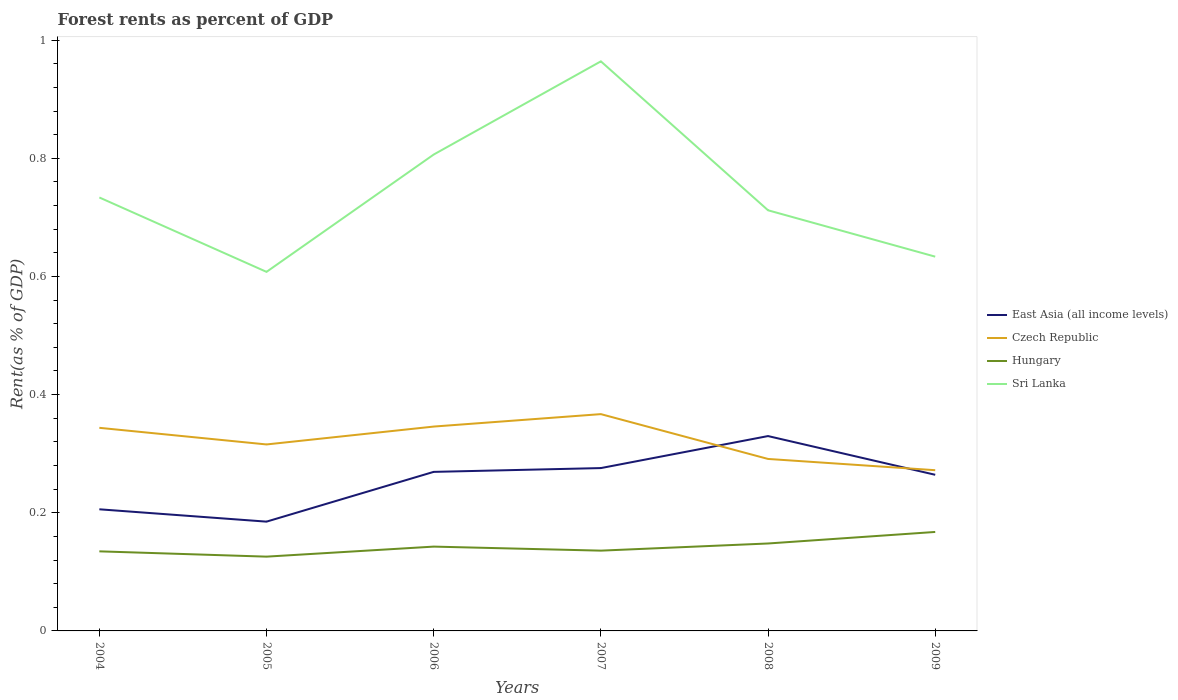How many different coloured lines are there?
Provide a succinct answer. 4. Is the number of lines equal to the number of legend labels?
Provide a short and direct response. Yes. Across all years, what is the maximum forest rent in East Asia (all income levels)?
Your answer should be compact. 0.18. What is the total forest rent in East Asia (all income levels) in the graph?
Provide a short and direct response. -0.01. What is the difference between the highest and the second highest forest rent in East Asia (all income levels)?
Provide a short and direct response. 0.14. How many years are there in the graph?
Provide a short and direct response. 6. What is the difference between two consecutive major ticks on the Y-axis?
Offer a very short reply. 0.2. Are the values on the major ticks of Y-axis written in scientific E-notation?
Provide a succinct answer. No. How many legend labels are there?
Keep it short and to the point. 4. What is the title of the graph?
Your answer should be compact. Forest rents as percent of GDP. Does "Haiti" appear as one of the legend labels in the graph?
Provide a short and direct response. No. What is the label or title of the Y-axis?
Offer a terse response. Rent(as % of GDP). What is the Rent(as % of GDP) in East Asia (all income levels) in 2004?
Make the answer very short. 0.21. What is the Rent(as % of GDP) in Czech Republic in 2004?
Provide a succinct answer. 0.34. What is the Rent(as % of GDP) of Hungary in 2004?
Your answer should be very brief. 0.13. What is the Rent(as % of GDP) in Sri Lanka in 2004?
Keep it short and to the point. 0.73. What is the Rent(as % of GDP) in East Asia (all income levels) in 2005?
Offer a very short reply. 0.18. What is the Rent(as % of GDP) in Czech Republic in 2005?
Ensure brevity in your answer.  0.32. What is the Rent(as % of GDP) of Hungary in 2005?
Give a very brief answer. 0.13. What is the Rent(as % of GDP) of Sri Lanka in 2005?
Offer a terse response. 0.61. What is the Rent(as % of GDP) of East Asia (all income levels) in 2006?
Your answer should be compact. 0.27. What is the Rent(as % of GDP) in Czech Republic in 2006?
Offer a very short reply. 0.35. What is the Rent(as % of GDP) of Hungary in 2006?
Your response must be concise. 0.14. What is the Rent(as % of GDP) in Sri Lanka in 2006?
Give a very brief answer. 0.81. What is the Rent(as % of GDP) in East Asia (all income levels) in 2007?
Offer a very short reply. 0.28. What is the Rent(as % of GDP) of Czech Republic in 2007?
Ensure brevity in your answer.  0.37. What is the Rent(as % of GDP) of Hungary in 2007?
Ensure brevity in your answer.  0.14. What is the Rent(as % of GDP) in Sri Lanka in 2007?
Your answer should be very brief. 0.96. What is the Rent(as % of GDP) in East Asia (all income levels) in 2008?
Offer a very short reply. 0.33. What is the Rent(as % of GDP) of Czech Republic in 2008?
Your response must be concise. 0.29. What is the Rent(as % of GDP) in Hungary in 2008?
Your response must be concise. 0.15. What is the Rent(as % of GDP) in Sri Lanka in 2008?
Make the answer very short. 0.71. What is the Rent(as % of GDP) in East Asia (all income levels) in 2009?
Make the answer very short. 0.26. What is the Rent(as % of GDP) in Czech Republic in 2009?
Make the answer very short. 0.27. What is the Rent(as % of GDP) in Hungary in 2009?
Your response must be concise. 0.17. What is the Rent(as % of GDP) of Sri Lanka in 2009?
Provide a short and direct response. 0.63. Across all years, what is the maximum Rent(as % of GDP) in East Asia (all income levels)?
Offer a terse response. 0.33. Across all years, what is the maximum Rent(as % of GDP) of Czech Republic?
Your answer should be very brief. 0.37. Across all years, what is the maximum Rent(as % of GDP) in Hungary?
Keep it short and to the point. 0.17. Across all years, what is the maximum Rent(as % of GDP) in Sri Lanka?
Make the answer very short. 0.96. Across all years, what is the minimum Rent(as % of GDP) in East Asia (all income levels)?
Provide a short and direct response. 0.18. Across all years, what is the minimum Rent(as % of GDP) in Czech Republic?
Offer a very short reply. 0.27. Across all years, what is the minimum Rent(as % of GDP) in Hungary?
Your answer should be very brief. 0.13. Across all years, what is the minimum Rent(as % of GDP) in Sri Lanka?
Keep it short and to the point. 0.61. What is the total Rent(as % of GDP) of East Asia (all income levels) in the graph?
Give a very brief answer. 1.53. What is the total Rent(as % of GDP) in Czech Republic in the graph?
Keep it short and to the point. 1.94. What is the total Rent(as % of GDP) of Hungary in the graph?
Offer a terse response. 0.85. What is the total Rent(as % of GDP) in Sri Lanka in the graph?
Make the answer very short. 4.46. What is the difference between the Rent(as % of GDP) in East Asia (all income levels) in 2004 and that in 2005?
Offer a very short reply. 0.02. What is the difference between the Rent(as % of GDP) in Czech Republic in 2004 and that in 2005?
Make the answer very short. 0.03. What is the difference between the Rent(as % of GDP) in Hungary in 2004 and that in 2005?
Your answer should be compact. 0.01. What is the difference between the Rent(as % of GDP) in Sri Lanka in 2004 and that in 2005?
Your answer should be very brief. 0.13. What is the difference between the Rent(as % of GDP) in East Asia (all income levels) in 2004 and that in 2006?
Offer a very short reply. -0.06. What is the difference between the Rent(as % of GDP) in Czech Republic in 2004 and that in 2006?
Offer a terse response. -0. What is the difference between the Rent(as % of GDP) of Hungary in 2004 and that in 2006?
Ensure brevity in your answer.  -0.01. What is the difference between the Rent(as % of GDP) of Sri Lanka in 2004 and that in 2006?
Keep it short and to the point. -0.07. What is the difference between the Rent(as % of GDP) in East Asia (all income levels) in 2004 and that in 2007?
Provide a short and direct response. -0.07. What is the difference between the Rent(as % of GDP) of Czech Republic in 2004 and that in 2007?
Offer a very short reply. -0.02. What is the difference between the Rent(as % of GDP) of Hungary in 2004 and that in 2007?
Provide a short and direct response. -0. What is the difference between the Rent(as % of GDP) in Sri Lanka in 2004 and that in 2007?
Ensure brevity in your answer.  -0.23. What is the difference between the Rent(as % of GDP) of East Asia (all income levels) in 2004 and that in 2008?
Give a very brief answer. -0.12. What is the difference between the Rent(as % of GDP) in Czech Republic in 2004 and that in 2008?
Your response must be concise. 0.05. What is the difference between the Rent(as % of GDP) in Hungary in 2004 and that in 2008?
Your answer should be compact. -0.01. What is the difference between the Rent(as % of GDP) in Sri Lanka in 2004 and that in 2008?
Keep it short and to the point. 0.02. What is the difference between the Rent(as % of GDP) of East Asia (all income levels) in 2004 and that in 2009?
Make the answer very short. -0.06. What is the difference between the Rent(as % of GDP) of Czech Republic in 2004 and that in 2009?
Offer a very short reply. 0.07. What is the difference between the Rent(as % of GDP) of Hungary in 2004 and that in 2009?
Provide a short and direct response. -0.03. What is the difference between the Rent(as % of GDP) in Sri Lanka in 2004 and that in 2009?
Give a very brief answer. 0.1. What is the difference between the Rent(as % of GDP) of East Asia (all income levels) in 2005 and that in 2006?
Make the answer very short. -0.08. What is the difference between the Rent(as % of GDP) of Czech Republic in 2005 and that in 2006?
Your response must be concise. -0.03. What is the difference between the Rent(as % of GDP) of Hungary in 2005 and that in 2006?
Your answer should be compact. -0.02. What is the difference between the Rent(as % of GDP) in Sri Lanka in 2005 and that in 2006?
Keep it short and to the point. -0.2. What is the difference between the Rent(as % of GDP) of East Asia (all income levels) in 2005 and that in 2007?
Make the answer very short. -0.09. What is the difference between the Rent(as % of GDP) of Czech Republic in 2005 and that in 2007?
Keep it short and to the point. -0.05. What is the difference between the Rent(as % of GDP) of Hungary in 2005 and that in 2007?
Ensure brevity in your answer.  -0.01. What is the difference between the Rent(as % of GDP) in Sri Lanka in 2005 and that in 2007?
Make the answer very short. -0.36. What is the difference between the Rent(as % of GDP) in East Asia (all income levels) in 2005 and that in 2008?
Provide a succinct answer. -0.14. What is the difference between the Rent(as % of GDP) in Czech Republic in 2005 and that in 2008?
Offer a very short reply. 0.02. What is the difference between the Rent(as % of GDP) in Hungary in 2005 and that in 2008?
Your response must be concise. -0.02. What is the difference between the Rent(as % of GDP) of Sri Lanka in 2005 and that in 2008?
Offer a very short reply. -0.1. What is the difference between the Rent(as % of GDP) of East Asia (all income levels) in 2005 and that in 2009?
Your response must be concise. -0.08. What is the difference between the Rent(as % of GDP) of Czech Republic in 2005 and that in 2009?
Offer a very short reply. 0.04. What is the difference between the Rent(as % of GDP) of Hungary in 2005 and that in 2009?
Ensure brevity in your answer.  -0.04. What is the difference between the Rent(as % of GDP) in Sri Lanka in 2005 and that in 2009?
Offer a very short reply. -0.03. What is the difference between the Rent(as % of GDP) in East Asia (all income levels) in 2006 and that in 2007?
Your response must be concise. -0.01. What is the difference between the Rent(as % of GDP) of Czech Republic in 2006 and that in 2007?
Offer a very short reply. -0.02. What is the difference between the Rent(as % of GDP) of Hungary in 2006 and that in 2007?
Offer a very short reply. 0.01. What is the difference between the Rent(as % of GDP) in Sri Lanka in 2006 and that in 2007?
Your response must be concise. -0.16. What is the difference between the Rent(as % of GDP) of East Asia (all income levels) in 2006 and that in 2008?
Your answer should be very brief. -0.06. What is the difference between the Rent(as % of GDP) of Czech Republic in 2006 and that in 2008?
Ensure brevity in your answer.  0.05. What is the difference between the Rent(as % of GDP) in Hungary in 2006 and that in 2008?
Keep it short and to the point. -0.01. What is the difference between the Rent(as % of GDP) in Sri Lanka in 2006 and that in 2008?
Keep it short and to the point. 0.09. What is the difference between the Rent(as % of GDP) of East Asia (all income levels) in 2006 and that in 2009?
Provide a succinct answer. 0.01. What is the difference between the Rent(as % of GDP) in Czech Republic in 2006 and that in 2009?
Keep it short and to the point. 0.07. What is the difference between the Rent(as % of GDP) in Hungary in 2006 and that in 2009?
Offer a very short reply. -0.02. What is the difference between the Rent(as % of GDP) of Sri Lanka in 2006 and that in 2009?
Ensure brevity in your answer.  0.17. What is the difference between the Rent(as % of GDP) of East Asia (all income levels) in 2007 and that in 2008?
Provide a short and direct response. -0.05. What is the difference between the Rent(as % of GDP) of Czech Republic in 2007 and that in 2008?
Offer a terse response. 0.08. What is the difference between the Rent(as % of GDP) of Hungary in 2007 and that in 2008?
Make the answer very short. -0.01. What is the difference between the Rent(as % of GDP) in Sri Lanka in 2007 and that in 2008?
Keep it short and to the point. 0.25. What is the difference between the Rent(as % of GDP) of East Asia (all income levels) in 2007 and that in 2009?
Provide a short and direct response. 0.01. What is the difference between the Rent(as % of GDP) of Czech Republic in 2007 and that in 2009?
Provide a short and direct response. 0.09. What is the difference between the Rent(as % of GDP) of Hungary in 2007 and that in 2009?
Your response must be concise. -0.03. What is the difference between the Rent(as % of GDP) of Sri Lanka in 2007 and that in 2009?
Provide a succinct answer. 0.33. What is the difference between the Rent(as % of GDP) of East Asia (all income levels) in 2008 and that in 2009?
Your answer should be very brief. 0.07. What is the difference between the Rent(as % of GDP) in Czech Republic in 2008 and that in 2009?
Offer a terse response. 0.02. What is the difference between the Rent(as % of GDP) in Hungary in 2008 and that in 2009?
Offer a very short reply. -0.02. What is the difference between the Rent(as % of GDP) of Sri Lanka in 2008 and that in 2009?
Give a very brief answer. 0.08. What is the difference between the Rent(as % of GDP) of East Asia (all income levels) in 2004 and the Rent(as % of GDP) of Czech Republic in 2005?
Keep it short and to the point. -0.11. What is the difference between the Rent(as % of GDP) in East Asia (all income levels) in 2004 and the Rent(as % of GDP) in Hungary in 2005?
Keep it short and to the point. 0.08. What is the difference between the Rent(as % of GDP) of East Asia (all income levels) in 2004 and the Rent(as % of GDP) of Sri Lanka in 2005?
Give a very brief answer. -0.4. What is the difference between the Rent(as % of GDP) of Czech Republic in 2004 and the Rent(as % of GDP) of Hungary in 2005?
Provide a succinct answer. 0.22. What is the difference between the Rent(as % of GDP) in Czech Republic in 2004 and the Rent(as % of GDP) in Sri Lanka in 2005?
Provide a short and direct response. -0.26. What is the difference between the Rent(as % of GDP) in Hungary in 2004 and the Rent(as % of GDP) in Sri Lanka in 2005?
Ensure brevity in your answer.  -0.47. What is the difference between the Rent(as % of GDP) in East Asia (all income levels) in 2004 and the Rent(as % of GDP) in Czech Republic in 2006?
Your response must be concise. -0.14. What is the difference between the Rent(as % of GDP) in East Asia (all income levels) in 2004 and the Rent(as % of GDP) in Hungary in 2006?
Ensure brevity in your answer.  0.06. What is the difference between the Rent(as % of GDP) of East Asia (all income levels) in 2004 and the Rent(as % of GDP) of Sri Lanka in 2006?
Make the answer very short. -0.6. What is the difference between the Rent(as % of GDP) of Czech Republic in 2004 and the Rent(as % of GDP) of Hungary in 2006?
Your answer should be compact. 0.2. What is the difference between the Rent(as % of GDP) in Czech Republic in 2004 and the Rent(as % of GDP) in Sri Lanka in 2006?
Keep it short and to the point. -0.46. What is the difference between the Rent(as % of GDP) in Hungary in 2004 and the Rent(as % of GDP) in Sri Lanka in 2006?
Ensure brevity in your answer.  -0.67. What is the difference between the Rent(as % of GDP) in East Asia (all income levels) in 2004 and the Rent(as % of GDP) in Czech Republic in 2007?
Offer a very short reply. -0.16. What is the difference between the Rent(as % of GDP) in East Asia (all income levels) in 2004 and the Rent(as % of GDP) in Hungary in 2007?
Offer a very short reply. 0.07. What is the difference between the Rent(as % of GDP) of East Asia (all income levels) in 2004 and the Rent(as % of GDP) of Sri Lanka in 2007?
Keep it short and to the point. -0.76. What is the difference between the Rent(as % of GDP) in Czech Republic in 2004 and the Rent(as % of GDP) in Hungary in 2007?
Offer a terse response. 0.21. What is the difference between the Rent(as % of GDP) in Czech Republic in 2004 and the Rent(as % of GDP) in Sri Lanka in 2007?
Provide a succinct answer. -0.62. What is the difference between the Rent(as % of GDP) of Hungary in 2004 and the Rent(as % of GDP) of Sri Lanka in 2007?
Provide a short and direct response. -0.83. What is the difference between the Rent(as % of GDP) in East Asia (all income levels) in 2004 and the Rent(as % of GDP) in Czech Republic in 2008?
Your response must be concise. -0.09. What is the difference between the Rent(as % of GDP) in East Asia (all income levels) in 2004 and the Rent(as % of GDP) in Hungary in 2008?
Your response must be concise. 0.06. What is the difference between the Rent(as % of GDP) of East Asia (all income levels) in 2004 and the Rent(as % of GDP) of Sri Lanka in 2008?
Your answer should be very brief. -0.51. What is the difference between the Rent(as % of GDP) in Czech Republic in 2004 and the Rent(as % of GDP) in Hungary in 2008?
Your response must be concise. 0.2. What is the difference between the Rent(as % of GDP) in Czech Republic in 2004 and the Rent(as % of GDP) in Sri Lanka in 2008?
Offer a terse response. -0.37. What is the difference between the Rent(as % of GDP) of Hungary in 2004 and the Rent(as % of GDP) of Sri Lanka in 2008?
Provide a short and direct response. -0.58. What is the difference between the Rent(as % of GDP) in East Asia (all income levels) in 2004 and the Rent(as % of GDP) in Czech Republic in 2009?
Make the answer very short. -0.07. What is the difference between the Rent(as % of GDP) in East Asia (all income levels) in 2004 and the Rent(as % of GDP) in Hungary in 2009?
Your answer should be compact. 0.04. What is the difference between the Rent(as % of GDP) in East Asia (all income levels) in 2004 and the Rent(as % of GDP) in Sri Lanka in 2009?
Offer a very short reply. -0.43. What is the difference between the Rent(as % of GDP) of Czech Republic in 2004 and the Rent(as % of GDP) of Hungary in 2009?
Offer a terse response. 0.18. What is the difference between the Rent(as % of GDP) in Czech Republic in 2004 and the Rent(as % of GDP) in Sri Lanka in 2009?
Make the answer very short. -0.29. What is the difference between the Rent(as % of GDP) in Hungary in 2004 and the Rent(as % of GDP) in Sri Lanka in 2009?
Your answer should be very brief. -0.5. What is the difference between the Rent(as % of GDP) in East Asia (all income levels) in 2005 and the Rent(as % of GDP) in Czech Republic in 2006?
Your response must be concise. -0.16. What is the difference between the Rent(as % of GDP) of East Asia (all income levels) in 2005 and the Rent(as % of GDP) of Hungary in 2006?
Ensure brevity in your answer.  0.04. What is the difference between the Rent(as % of GDP) of East Asia (all income levels) in 2005 and the Rent(as % of GDP) of Sri Lanka in 2006?
Make the answer very short. -0.62. What is the difference between the Rent(as % of GDP) in Czech Republic in 2005 and the Rent(as % of GDP) in Hungary in 2006?
Offer a terse response. 0.17. What is the difference between the Rent(as % of GDP) of Czech Republic in 2005 and the Rent(as % of GDP) of Sri Lanka in 2006?
Your response must be concise. -0.49. What is the difference between the Rent(as % of GDP) in Hungary in 2005 and the Rent(as % of GDP) in Sri Lanka in 2006?
Your answer should be compact. -0.68. What is the difference between the Rent(as % of GDP) in East Asia (all income levels) in 2005 and the Rent(as % of GDP) in Czech Republic in 2007?
Provide a short and direct response. -0.18. What is the difference between the Rent(as % of GDP) of East Asia (all income levels) in 2005 and the Rent(as % of GDP) of Hungary in 2007?
Give a very brief answer. 0.05. What is the difference between the Rent(as % of GDP) in East Asia (all income levels) in 2005 and the Rent(as % of GDP) in Sri Lanka in 2007?
Your response must be concise. -0.78. What is the difference between the Rent(as % of GDP) of Czech Republic in 2005 and the Rent(as % of GDP) of Hungary in 2007?
Your response must be concise. 0.18. What is the difference between the Rent(as % of GDP) in Czech Republic in 2005 and the Rent(as % of GDP) in Sri Lanka in 2007?
Ensure brevity in your answer.  -0.65. What is the difference between the Rent(as % of GDP) of Hungary in 2005 and the Rent(as % of GDP) of Sri Lanka in 2007?
Provide a succinct answer. -0.84. What is the difference between the Rent(as % of GDP) of East Asia (all income levels) in 2005 and the Rent(as % of GDP) of Czech Republic in 2008?
Provide a short and direct response. -0.11. What is the difference between the Rent(as % of GDP) of East Asia (all income levels) in 2005 and the Rent(as % of GDP) of Hungary in 2008?
Your answer should be compact. 0.04. What is the difference between the Rent(as % of GDP) of East Asia (all income levels) in 2005 and the Rent(as % of GDP) of Sri Lanka in 2008?
Ensure brevity in your answer.  -0.53. What is the difference between the Rent(as % of GDP) in Czech Republic in 2005 and the Rent(as % of GDP) in Hungary in 2008?
Make the answer very short. 0.17. What is the difference between the Rent(as % of GDP) in Czech Republic in 2005 and the Rent(as % of GDP) in Sri Lanka in 2008?
Your answer should be very brief. -0.4. What is the difference between the Rent(as % of GDP) in Hungary in 2005 and the Rent(as % of GDP) in Sri Lanka in 2008?
Your response must be concise. -0.59. What is the difference between the Rent(as % of GDP) of East Asia (all income levels) in 2005 and the Rent(as % of GDP) of Czech Republic in 2009?
Provide a short and direct response. -0.09. What is the difference between the Rent(as % of GDP) of East Asia (all income levels) in 2005 and the Rent(as % of GDP) of Hungary in 2009?
Offer a terse response. 0.02. What is the difference between the Rent(as % of GDP) in East Asia (all income levels) in 2005 and the Rent(as % of GDP) in Sri Lanka in 2009?
Ensure brevity in your answer.  -0.45. What is the difference between the Rent(as % of GDP) of Czech Republic in 2005 and the Rent(as % of GDP) of Hungary in 2009?
Provide a succinct answer. 0.15. What is the difference between the Rent(as % of GDP) in Czech Republic in 2005 and the Rent(as % of GDP) in Sri Lanka in 2009?
Provide a short and direct response. -0.32. What is the difference between the Rent(as % of GDP) in Hungary in 2005 and the Rent(as % of GDP) in Sri Lanka in 2009?
Offer a terse response. -0.51. What is the difference between the Rent(as % of GDP) of East Asia (all income levels) in 2006 and the Rent(as % of GDP) of Czech Republic in 2007?
Offer a terse response. -0.1. What is the difference between the Rent(as % of GDP) in East Asia (all income levels) in 2006 and the Rent(as % of GDP) in Hungary in 2007?
Provide a succinct answer. 0.13. What is the difference between the Rent(as % of GDP) in East Asia (all income levels) in 2006 and the Rent(as % of GDP) in Sri Lanka in 2007?
Offer a very short reply. -0.69. What is the difference between the Rent(as % of GDP) of Czech Republic in 2006 and the Rent(as % of GDP) of Hungary in 2007?
Your answer should be very brief. 0.21. What is the difference between the Rent(as % of GDP) in Czech Republic in 2006 and the Rent(as % of GDP) in Sri Lanka in 2007?
Your response must be concise. -0.62. What is the difference between the Rent(as % of GDP) of Hungary in 2006 and the Rent(as % of GDP) of Sri Lanka in 2007?
Give a very brief answer. -0.82. What is the difference between the Rent(as % of GDP) of East Asia (all income levels) in 2006 and the Rent(as % of GDP) of Czech Republic in 2008?
Offer a very short reply. -0.02. What is the difference between the Rent(as % of GDP) in East Asia (all income levels) in 2006 and the Rent(as % of GDP) in Hungary in 2008?
Offer a very short reply. 0.12. What is the difference between the Rent(as % of GDP) in East Asia (all income levels) in 2006 and the Rent(as % of GDP) in Sri Lanka in 2008?
Your answer should be very brief. -0.44. What is the difference between the Rent(as % of GDP) in Czech Republic in 2006 and the Rent(as % of GDP) in Hungary in 2008?
Offer a terse response. 0.2. What is the difference between the Rent(as % of GDP) of Czech Republic in 2006 and the Rent(as % of GDP) of Sri Lanka in 2008?
Give a very brief answer. -0.37. What is the difference between the Rent(as % of GDP) in Hungary in 2006 and the Rent(as % of GDP) in Sri Lanka in 2008?
Your answer should be very brief. -0.57. What is the difference between the Rent(as % of GDP) of East Asia (all income levels) in 2006 and the Rent(as % of GDP) of Czech Republic in 2009?
Keep it short and to the point. -0. What is the difference between the Rent(as % of GDP) in East Asia (all income levels) in 2006 and the Rent(as % of GDP) in Hungary in 2009?
Your answer should be very brief. 0.1. What is the difference between the Rent(as % of GDP) of East Asia (all income levels) in 2006 and the Rent(as % of GDP) of Sri Lanka in 2009?
Provide a short and direct response. -0.36. What is the difference between the Rent(as % of GDP) of Czech Republic in 2006 and the Rent(as % of GDP) of Hungary in 2009?
Give a very brief answer. 0.18. What is the difference between the Rent(as % of GDP) of Czech Republic in 2006 and the Rent(as % of GDP) of Sri Lanka in 2009?
Keep it short and to the point. -0.29. What is the difference between the Rent(as % of GDP) of Hungary in 2006 and the Rent(as % of GDP) of Sri Lanka in 2009?
Your answer should be very brief. -0.49. What is the difference between the Rent(as % of GDP) of East Asia (all income levels) in 2007 and the Rent(as % of GDP) of Czech Republic in 2008?
Ensure brevity in your answer.  -0.02. What is the difference between the Rent(as % of GDP) in East Asia (all income levels) in 2007 and the Rent(as % of GDP) in Hungary in 2008?
Offer a very short reply. 0.13. What is the difference between the Rent(as % of GDP) of East Asia (all income levels) in 2007 and the Rent(as % of GDP) of Sri Lanka in 2008?
Offer a very short reply. -0.44. What is the difference between the Rent(as % of GDP) in Czech Republic in 2007 and the Rent(as % of GDP) in Hungary in 2008?
Your response must be concise. 0.22. What is the difference between the Rent(as % of GDP) of Czech Republic in 2007 and the Rent(as % of GDP) of Sri Lanka in 2008?
Give a very brief answer. -0.35. What is the difference between the Rent(as % of GDP) in Hungary in 2007 and the Rent(as % of GDP) in Sri Lanka in 2008?
Your answer should be very brief. -0.58. What is the difference between the Rent(as % of GDP) in East Asia (all income levels) in 2007 and the Rent(as % of GDP) in Czech Republic in 2009?
Keep it short and to the point. 0. What is the difference between the Rent(as % of GDP) of East Asia (all income levels) in 2007 and the Rent(as % of GDP) of Hungary in 2009?
Keep it short and to the point. 0.11. What is the difference between the Rent(as % of GDP) in East Asia (all income levels) in 2007 and the Rent(as % of GDP) in Sri Lanka in 2009?
Offer a terse response. -0.36. What is the difference between the Rent(as % of GDP) in Czech Republic in 2007 and the Rent(as % of GDP) in Hungary in 2009?
Keep it short and to the point. 0.2. What is the difference between the Rent(as % of GDP) of Czech Republic in 2007 and the Rent(as % of GDP) of Sri Lanka in 2009?
Your response must be concise. -0.27. What is the difference between the Rent(as % of GDP) of Hungary in 2007 and the Rent(as % of GDP) of Sri Lanka in 2009?
Your answer should be very brief. -0.5. What is the difference between the Rent(as % of GDP) of East Asia (all income levels) in 2008 and the Rent(as % of GDP) of Czech Republic in 2009?
Your answer should be compact. 0.06. What is the difference between the Rent(as % of GDP) in East Asia (all income levels) in 2008 and the Rent(as % of GDP) in Hungary in 2009?
Your answer should be very brief. 0.16. What is the difference between the Rent(as % of GDP) of East Asia (all income levels) in 2008 and the Rent(as % of GDP) of Sri Lanka in 2009?
Offer a very short reply. -0.3. What is the difference between the Rent(as % of GDP) of Czech Republic in 2008 and the Rent(as % of GDP) of Hungary in 2009?
Keep it short and to the point. 0.12. What is the difference between the Rent(as % of GDP) in Czech Republic in 2008 and the Rent(as % of GDP) in Sri Lanka in 2009?
Offer a very short reply. -0.34. What is the difference between the Rent(as % of GDP) of Hungary in 2008 and the Rent(as % of GDP) of Sri Lanka in 2009?
Give a very brief answer. -0.49. What is the average Rent(as % of GDP) of East Asia (all income levels) per year?
Your answer should be compact. 0.26. What is the average Rent(as % of GDP) in Czech Republic per year?
Your response must be concise. 0.32. What is the average Rent(as % of GDP) in Hungary per year?
Your answer should be very brief. 0.14. What is the average Rent(as % of GDP) of Sri Lanka per year?
Offer a terse response. 0.74. In the year 2004, what is the difference between the Rent(as % of GDP) in East Asia (all income levels) and Rent(as % of GDP) in Czech Republic?
Your answer should be compact. -0.14. In the year 2004, what is the difference between the Rent(as % of GDP) in East Asia (all income levels) and Rent(as % of GDP) in Hungary?
Provide a short and direct response. 0.07. In the year 2004, what is the difference between the Rent(as % of GDP) of East Asia (all income levels) and Rent(as % of GDP) of Sri Lanka?
Provide a short and direct response. -0.53. In the year 2004, what is the difference between the Rent(as % of GDP) of Czech Republic and Rent(as % of GDP) of Hungary?
Offer a terse response. 0.21. In the year 2004, what is the difference between the Rent(as % of GDP) in Czech Republic and Rent(as % of GDP) in Sri Lanka?
Offer a terse response. -0.39. In the year 2004, what is the difference between the Rent(as % of GDP) of Hungary and Rent(as % of GDP) of Sri Lanka?
Give a very brief answer. -0.6. In the year 2005, what is the difference between the Rent(as % of GDP) in East Asia (all income levels) and Rent(as % of GDP) in Czech Republic?
Offer a terse response. -0.13. In the year 2005, what is the difference between the Rent(as % of GDP) in East Asia (all income levels) and Rent(as % of GDP) in Hungary?
Give a very brief answer. 0.06. In the year 2005, what is the difference between the Rent(as % of GDP) of East Asia (all income levels) and Rent(as % of GDP) of Sri Lanka?
Provide a short and direct response. -0.42. In the year 2005, what is the difference between the Rent(as % of GDP) of Czech Republic and Rent(as % of GDP) of Hungary?
Keep it short and to the point. 0.19. In the year 2005, what is the difference between the Rent(as % of GDP) of Czech Republic and Rent(as % of GDP) of Sri Lanka?
Provide a succinct answer. -0.29. In the year 2005, what is the difference between the Rent(as % of GDP) in Hungary and Rent(as % of GDP) in Sri Lanka?
Give a very brief answer. -0.48. In the year 2006, what is the difference between the Rent(as % of GDP) of East Asia (all income levels) and Rent(as % of GDP) of Czech Republic?
Your answer should be compact. -0.08. In the year 2006, what is the difference between the Rent(as % of GDP) of East Asia (all income levels) and Rent(as % of GDP) of Hungary?
Your response must be concise. 0.13. In the year 2006, what is the difference between the Rent(as % of GDP) of East Asia (all income levels) and Rent(as % of GDP) of Sri Lanka?
Your response must be concise. -0.54. In the year 2006, what is the difference between the Rent(as % of GDP) in Czech Republic and Rent(as % of GDP) in Hungary?
Your answer should be very brief. 0.2. In the year 2006, what is the difference between the Rent(as % of GDP) of Czech Republic and Rent(as % of GDP) of Sri Lanka?
Your answer should be compact. -0.46. In the year 2006, what is the difference between the Rent(as % of GDP) in Hungary and Rent(as % of GDP) in Sri Lanka?
Offer a terse response. -0.66. In the year 2007, what is the difference between the Rent(as % of GDP) of East Asia (all income levels) and Rent(as % of GDP) of Czech Republic?
Your response must be concise. -0.09. In the year 2007, what is the difference between the Rent(as % of GDP) of East Asia (all income levels) and Rent(as % of GDP) of Hungary?
Offer a terse response. 0.14. In the year 2007, what is the difference between the Rent(as % of GDP) of East Asia (all income levels) and Rent(as % of GDP) of Sri Lanka?
Your response must be concise. -0.69. In the year 2007, what is the difference between the Rent(as % of GDP) in Czech Republic and Rent(as % of GDP) in Hungary?
Your answer should be very brief. 0.23. In the year 2007, what is the difference between the Rent(as % of GDP) of Czech Republic and Rent(as % of GDP) of Sri Lanka?
Your answer should be very brief. -0.6. In the year 2007, what is the difference between the Rent(as % of GDP) of Hungary and Rent(as % of GDP) of Sri Lanka?
Provide a short and direct response. -0.83. In the year 2008, what is the difference between the Rent(as % of GDP) in East Asia (all income levels) and Rent(as % of GDP) in Czech Republic?
Give a very brief answer. 0.04. In the year 2008, what is the difference between the Rent(as % of GDP) of East Asia (all income levels) and Rent(as % of GDP) of Hungary?
Your response must be concise. 0.18. In the year 2008, what is the difference between the Rent(as % of GDP) of East Asia (all income levels) and Rent(as % of GDP) of Sri Lanka?
Provide a succinct answer. -0.38. In the year 2008, what is the difference between the Rent(as % of GDP) of Czech Republic and Rent(as % of GDP) of Hungary?
Provide a succinct answer. 0.14. In the year 2008, what is the difference between the Rent(as % of GDP) in Czech Republic and Rent(as % of GDP) in Sri Lanka?
Your answer should be very brief. -0.42. In the year 2008, what is the difference between the Rent(as % of GDP) of Hungary and Rent(as % of GDP) of Sri Lanka?
Make the answer very short. -0.56. In the year 2009, what is the difference between the Rent(as % of GDP) in East Asia (all income levels) and Rent(as % of GDP) in Czech Republic?
Offer a terse response. -0.01. In the year 2009, what is the difference between the Rent(as % of GDP) in East Asia (all income levels) and Rent(as % of GDP) in Hungary?
Provide a succinct answer. 0.1. In the year 2009, what is the difference between the Rent(as % of GDP) of East Asia (all income levels) and Rent(as % of GDP) of Sri Lanka?
Offer a very short reply. -0.37. In the year 2009, what is the difference between the Rent(as % of GDP) in Czech Republic and Rent(as % of GDP) in Hungary?
Offer a very short reply. 0.1. In the year 2009, what is the difference between the Rent(as % of GDP) in Czech Republic and Rent(as % of GDP) in Sri Lanka?
Provide a short and direct response. -0.36. In the year 2009, what is the difference between the Rent(as % of GDP) of Hungary and Rent(as % of GDP) of Sri Lanka?
Give a very brief answer. -0.47. What is the ratio of the Rent(as % of GDP) of East Asia (all income levels) in 2004 to that in 2005?
Provide a succinct answer. 1.11. What is the ratio of the Rent(as % of GDP) of Czech Republic in 2004 to that in 2005?
Provide a succinct answer. 1.09. What is the ratio of the Rent(as % of GDP) in Hungary in 2004 to that in 2005?
Provide a succinct answer. 1.07. What is the ratio of the Rent(as % of GDP) of Sri Lanka in 2004 to that in 2005?
Offer a very short reply. 1.21. What is the ratio of the Rent(as % of GDP) in East Asia (all income levels) in 2004 to that in 2006?
Provide a short and direct response. 0.76. What is the ratio of the Rent(as % of GDP) in Czech Republic in 2004 to that in 2006?
Provide a succinct answer. 0.99. What is the ratio of the Rent(as % of GDP) in Hungary in 2004 to that in 2006?
Your response must be concise. 0.94. What is the ratio of the Rent(as % of GDP) in Sri Lanka in 2004 to that in 2006?
Give a very brief answer. 0.91. What is the ratio of the Rent(as % of GDP) of East Asia (all income levels) in 2004 to that in 2007?
Provide a succinct answer. 0.75. What is the ratio of the Rent(as % of GDP) of Czech Republic in 2004 to that in 2007?
Provide a short and direct response. 0.94. What is the ratio of the Rent(as % of GDP) of Sri Lanka in 2004 to that in 2007?
Ensure brevity in your answer.  0.76. What is the ratio of the Rent(as % of GDP) of East Asia (all income levels) in 2004 to that in 2008?
Your response must be concise. 0.62. What is the ratio of the Rent(as % of GDP) in Czech Republic in 2004 to that in 2008?
Offer a terse response. 1.18. What is the ratio of the Rent(as % of GDP) in Hungary in 2004 to that in 2008?
Ensure brevity in your answer.  0.91. What is the ratio of the Rent(as % of GDP) in Sri Lanka in 2004 to that in 2008?
Provide a succinct answer. 1.03. What is the ratio of the Rent(as % of GDP) of East Asia (all income levels) in 2004 to that in 2009?
Offer a terse response. 0.78. What is the ratio of the Rent(as % of GDP) of Czech Republic in 2004 to that in 2009?
Ensure brevity in your answer.  1.26. What is the ratio of the Rent(as % of GDP) in Hungary in 2004 to that in 2009?
Provide a succinct answer. 0.8. What is the ratio of the Rent(as % of GDP) in Sri Lanka in 2004 to that in 2009?
Keep it short and to the point. 1.16. What is the ratio of the Rent(as % of GDP) in East Asia (all income levels) in 2005 to that in 2006?
Make the answer very short. 0.69. What is the ratio of the Rent(as % of GDP) in Czech Republic in 2005 to that in 2006?
Make the answer very short. 0.91. What is the ratio of the Rent(as % of GDP) in Hungary in 2005 to that in 2006?
Offer a terse response. 0.88. What is the ratio of the Rent(as % of GDP) in Sri Lanka in 2005 to that in 2006?
Keep it short and to the point. 0.75. What is the ratio of the Rent(as % of GDP) of East Asia (all income levels) in 2005 to that in 2007?
Your answer should be very brief. 0.67. What is the ratio of the Rent(as % of GDP) of Czech Republic in 2005 to that in 2007?
Ensure brevity in your answer.  0.86. What is the ratio of the Rent(as % of GDP) in Hungary in 2005 to that in 2007?
Your answer should be very brief. 0.93. What is the ratio of the Rent(as % of GDP) of Sri Lanka in 2005 to that in 2007?
Your response must be concise. 0.63. What is the ratio of the Rent(as % of GDP) of East Asia (all income levels) in 2005 to that in 2008?
Provide a succinct answer. 0.56. What is the ratio of the Rent(as % of GDP) of Czech Republic in 2005 to that in 2008?
Offer a very short reply. 1.08. What is the ratio of the Rent(as % of GDP) in Hungary in 2005 to that in 2008?
Keep it short and to the point. 0.85. What is the ratio of the Rent(as % of GDP) of Sri Lanka in 2005 to that in 2008?
Your answer should be compact. 0.85. What is the ratio of the Rent(as % of GDP) of Czech Republic in 2005 to that in 2009?
Ensure brevity in your answer.  1.16. What is the ratio of the Rent(as % of GDP) in Hungary in 2005 to that in 2009?
Your response must be concise. 0.75. What is the ratio of the Rent(as % of GDP) of Sri Lanka in 2005 to that in 2009?
Give a very brief answer. 0.96. What is the ratio of the Rent(as % of GDP) in East Asia (all income levels) in 2006 to that in 2007?
Make the answer very short. 0.98. What is the ratio of the Rent(as % of GDP) of Czech Republic in 2006 to that in 2007?
Offer a very short reply. 0.94. What is the ratio of the Rent(as % of GDP) in Hungary in 2006 to that in 2007?
Offer a terse response. 1.05. What is the ratio of the Rent(as % of GDP) in Sri Lanka in 2006 to that in 2007?
Your answer should be very brief. 0.84. What is the ratio of the Rent(as % of GDP) in East Asia (all income levels) in 2006 to that in 2008?
Provide a succinct answer. 0.82. What is the ratio of the Rent(as % of GDP) in Czech Republic in 2006 to that in 2008?
Ensure brevity in your answer.  1.19. What is the ratio of the Rent(as % of GDP) in Hungary in 2006 to that in 2008?
Keep it short and to the point. 0.96. What is the ratio of the Rent(as % of GDP) in Sri Lanka in 2006 to that in 2008?
Offer a very short reply. 1.13. What is the ratio of the Rent(as % of GDP) in East Asia (all income levels) in 2006 to that in 2009?
Offer a terse response. 1.02. What is the ratio of the Rent(as % of GDP) in Czech Republic in 2006 to that in 2009?
Your response must be concise. 1.27. What is the ratio of the Rent(as % of GDP) in Hungary in 2006 to that in 2009?
Make the answer very short. 0.85. What is the ratio of the Rent(as % of GDP) of Sri Lanka in 2006 to that in 2009?
Ensure brevity in your answer.  1.27. What is the ratio of the Rent(as % of GDP) in East Asia (all income levels) in 2007 to that in 2008?
Give a very brief answer. 0.84. What is the ratio of the Rent(as % of GDP) in Czech Republic in 2007 to that in 2008?
Make the answer very short. 1.26. What is the ratio of the Rent(as % of GDP) in Hungary in 2007 to that in 2008?
Your response must be concise. 0.92. What is the ratio of the Rent(as % of GDP) of Sri Lanka in 2007 to that in 2008?
Keep it short and to the point. 1.35. What is the ratio of the Rent(as % of GDP) in East Asia (all income levels) in 2007 to that in 2009?
Provide a short and direct response. 1.04. What is the ratio of the Rent(as % of GDP) in Czech Republic in 2007 to that in 2009?
Offer a very short reply. 1.35. What is the ratio of the Rent(as % of GDP) of Hungary in 2007 to that in 2009?
Your response must be concise. 0.81. What is the ratio of the Rent(as % of GDP) of Sri Lanka in 2007 to that in 2009?
Your answer should be very brief. 1.52. What is the ratio of the Rent(as % of GDP) in East Asia (all income levels) in 2008 to that in 2009?
Provide a short and direct response. 1.25. What is the ratio of the Rent(as % of GDP) in Czech Republic in 2008 to that in 2009?
Keep it short and to the point. 1.07. What is the ratio of the Rent(as % of GDP) in Hungary in 2008 to that in 2009?
Make the answer very short. 0.88. What is the ratio of the Rent(as % of GDP) in Sri Lanka in 2008 to that in 2009?
Offer a terse response. 1.12. What is the difference between the highest and the second highest Rent(as % of GDP) in East Asia (all income levels)?
Make the answer very short. 0.05. What is the difference between the highest and the second highest Rent(as % of GDP) of Czech Republic?
Keep it short and to the point. 0.02. What is the difference between the highest and the second highest Rent(as % of GDP) of Hungary?
Keep it short and to the point. 0.02. What is the difference between the highest and the second highest Rent(as % of GDP) in Sri Lanka?
Offer a very short reply. 0.16. What is the difference between the highest and the lowest Rent(as % of GDP) in East Asia (all income levels)?
Ensure brevity in your answer.  0.14. What is the difference between the highest and the lowest Rent(as % of GDP) in Czech Republic?
Keep it short and to the point. 0.09. What is the difference between the highest and the lowest Rent(as % of GDP) in Hungary?
Your answer should be compact. 0.04. What is the difference between the highest and the lowest Rent(as % of GDP) of Sri Lanka?
Your response must be concise. 0.36. 